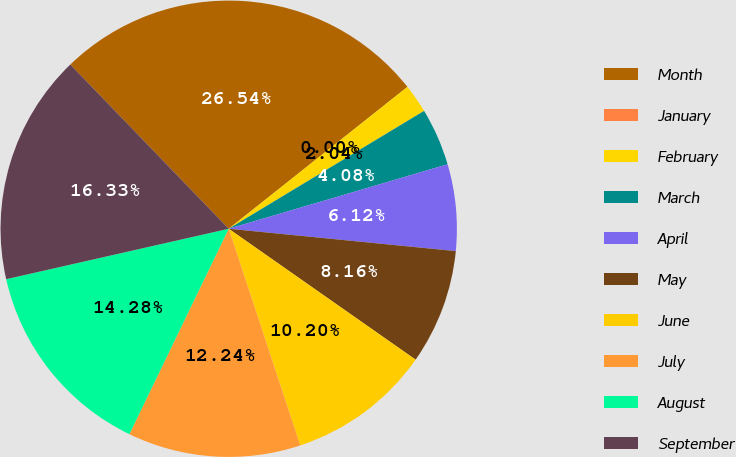Convert chart. <chart><loc_0><loc_0><loc_500><loc_500><pie_chart><fcel>Month<fcel>January<fcel>February<fcel>March<fcel>April<fcel>May<fcel>June<fcel>July<fcel>August<fcel>September<nl><fcel>26.53%<fcel>0.0%<fcel>2.04%<fcel>4.08%<fcel>6.12%<fcel>8.16%<fcel>10.2%<fcel>12.24%<fcel>14.28%<fcel>16.33%<nl></chart> 